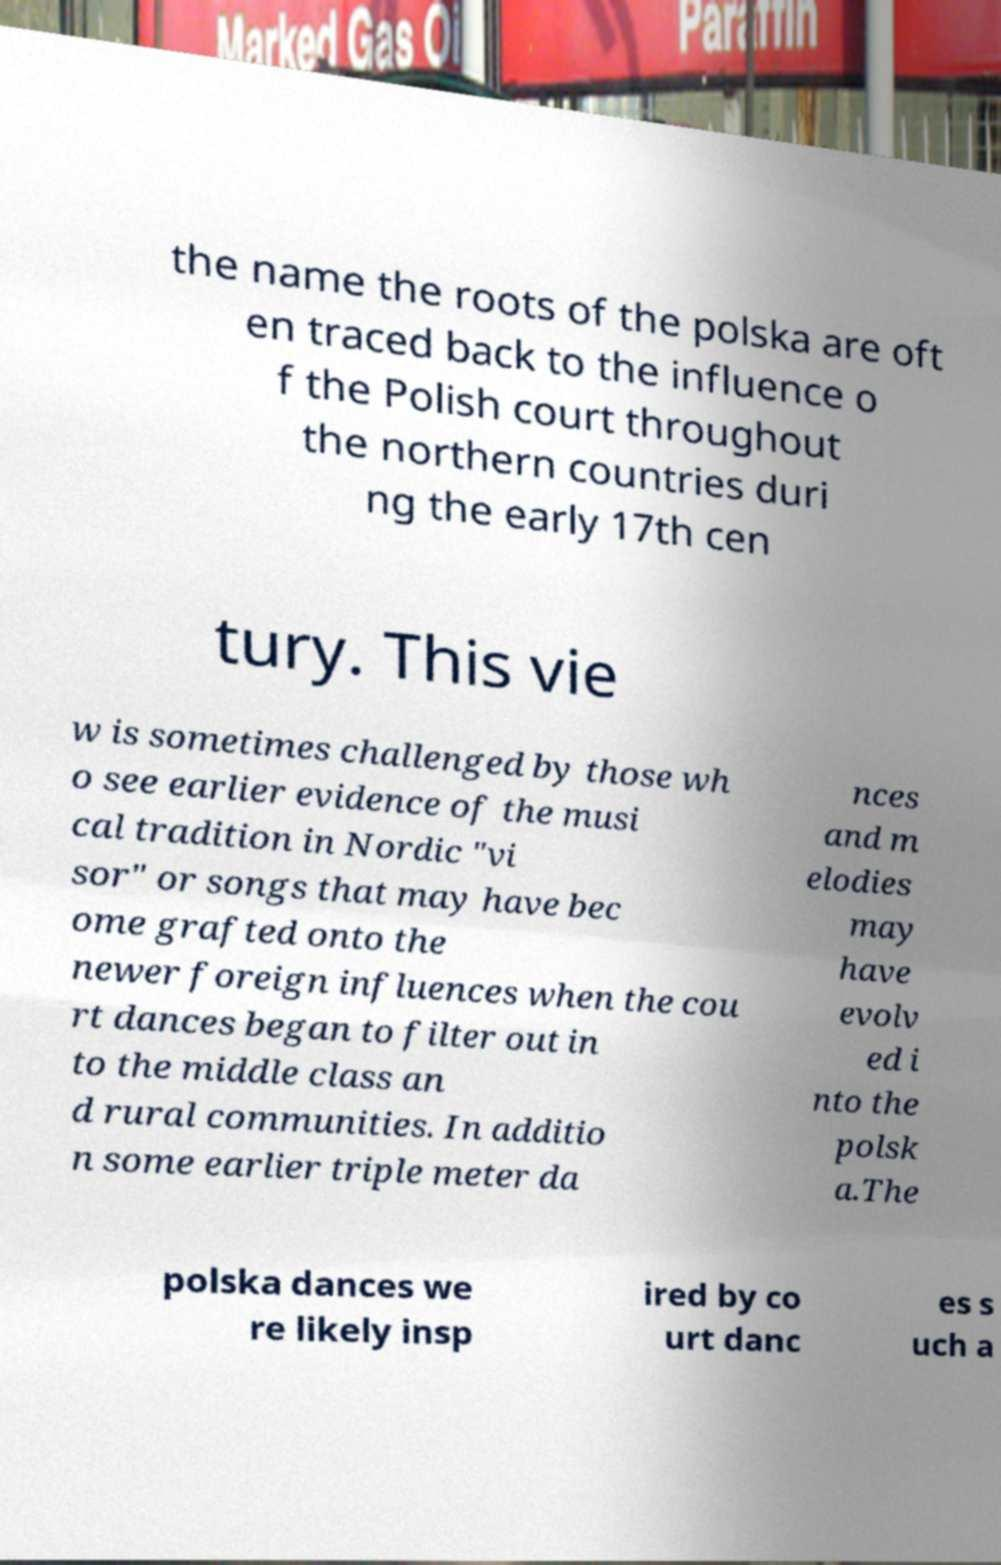Can you accurately transcribe the text from the provided image for me? the name the roots of the polska are oft en traced back to the influence o f the Polish court throughout the northern countries duri ng the early 17th cen tury. This vie w is sometimes challenged by those wh o see earlier evidence of the musi cal tradition in Nordic "vi sor" or songs that may have bec ome grafted onto the newer foreign influences when the cou rt dances began to filter out in to the middle class an d rural communities. In additio n some earlier triple meter da nces and m elodies may have evolv ed i nto the polsk a.The polska dances we re likely insp ired by co urt danc es s uch a 